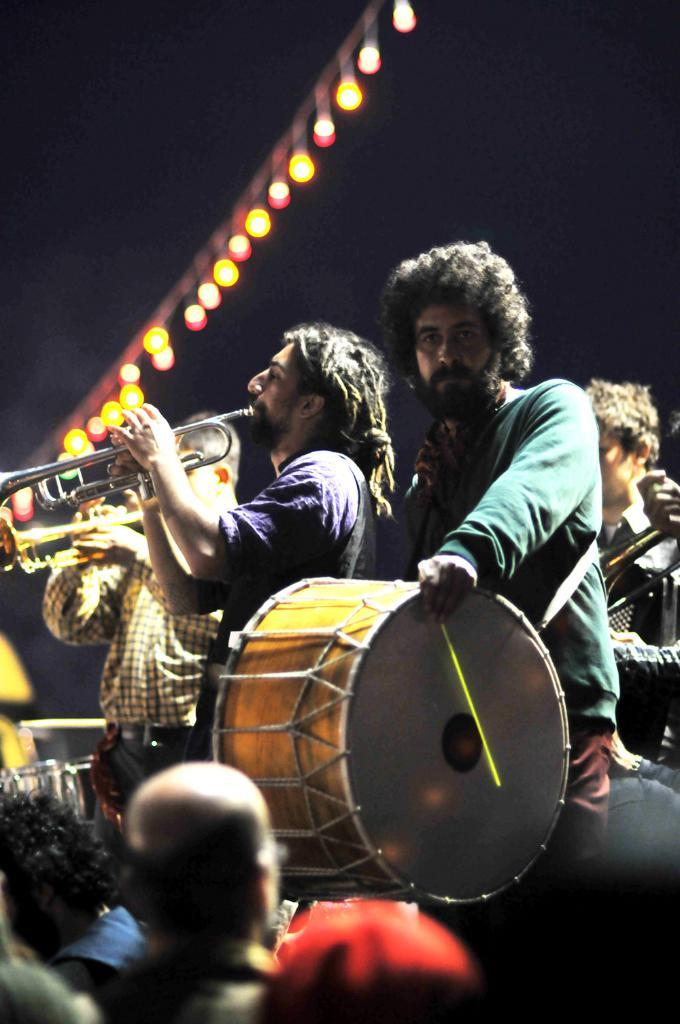How many people are in the image? There are three people in the image. What are the people doing in the image? The people are standing and playing musical instruments. Who is watching the performance in the image? There is an audience watching their performance. What can be seen in the background of the image? Lights are hanging in the background. How many bubbles can be seen floating around the musicians in the image? There are no bubbles present in the image. What type of balance exercise is the person in the middle performing in the image? There is no balance exercise being performed in the image; the person in the middle is playing a musical instrument while standing. 